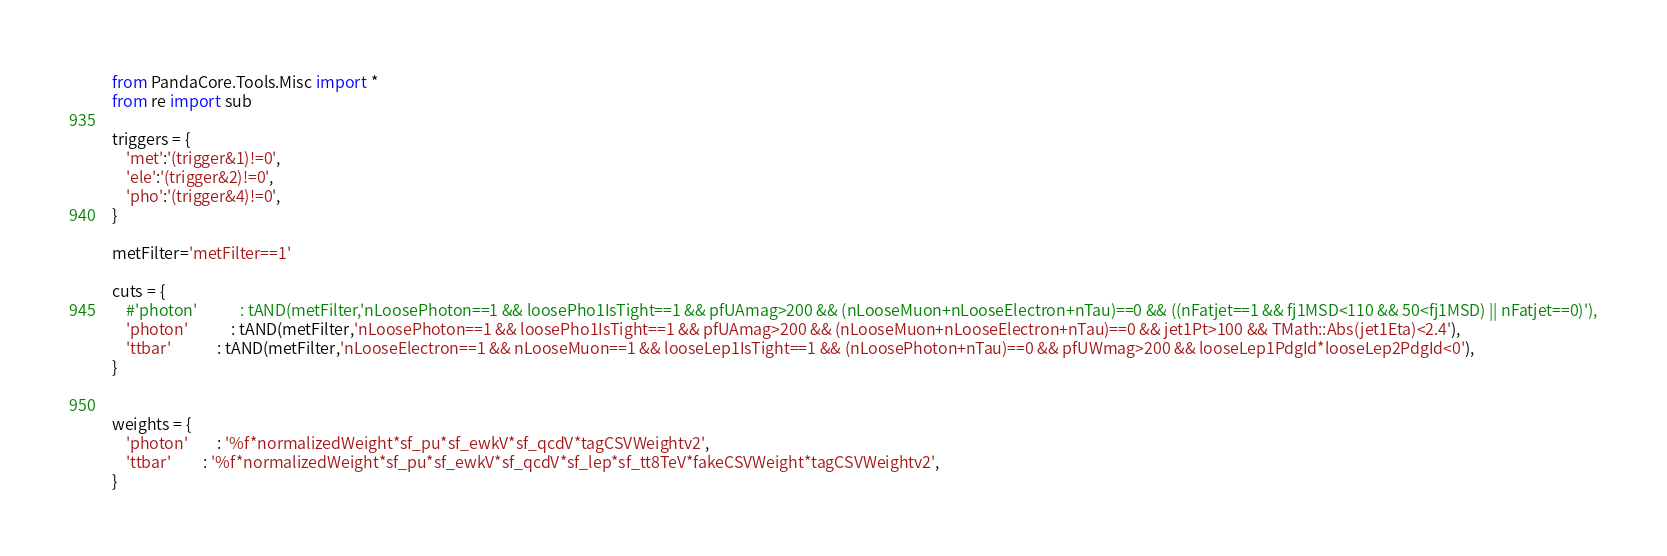<code> <loc_0><loc_0><loc_500><loc_500><_Python_>from PandaCore.Tools.Misc import *
from re import sub

triggers = {
    'met':'(trigger&1)!=0',
    'ele':'(trigger&2)!=0',
    'pho':'(trigger&4)!=0',
}

metFilter='metFilter==1'

cuts = {
    #'photon'            : tAND(metFilter,'nLoosePhoton==1 && loosePho1IsTight==1 && pfUAmag>200 && (nLooseMuon+nLooseElectron+nTau)==0 && ((nFatjet==1 && fj1MSD<110 && 50<fj1MSD) || nFatjet==0)'),
    'photon'            : tAND(metFilter,'nLoosePhoton==1 && loosePho1IsTight==1 && pfUAmag>200 && (nLooseMuon+nLooseElectron+nTau)==0 && jet1Pt>100 && TMath::Abs(jet1Eta)<2.4'),
    'ttbar'             : tAND(metFilter,'nLooseElectron==1 && nLooseMuon==1 && looseLep1IsTight==1 && (nLoosePhoton+nTau)==0 && pfUWmag>200 && looseLep1PdgId*looseLep2PdgId<0'),
}


weights = {
    'photon'        : '%f*normalizedWeight*sf_pu*sf_ewkV*sf_qcdV*tagCSVWeightv2',
    'ttbar'         : '%f*normalizedWeight*sf_pu*sf_ewkV*sf_qcdV*sf_lep*sf_tt8TeV*fakeCSVWeight*tagCSVWeightv2',
}
</code> 